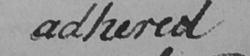What text is written in this handwritten line? adhered 